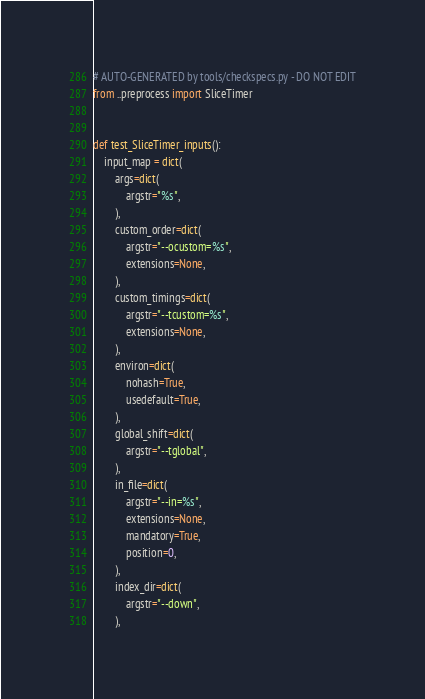Convert code to text. <code><loc_0><loc_0><loc_500><loc_500><_Python_># AUTO-GENERATED by tools/checkspecs.py - DO NOT EDIT
from ..preprocess import SliceTimer


def test_SliceTimer_inputs():
    input_map = dict(
        args=dict(
            argstr="%s",
        ),
        custom_order=dict(
            argstr="--ocustom=%s",
            extensions=None,
        ),
        custom_timings=dict(
            argstr="--tcustom=%s",
            extensions=None,
        ),
        environ=dict(
            nohash=True,
            usedefault=True,
        ),
        global_shift=dict(
            argstr="--tglobal",
        ),
        in_file=dict(
            argstr="--in=%s",
            extensions=None,
            mandatory=True,
            position=0,
        ),
        index_dir=dict(
            argstr="--down",
        ),</code> 